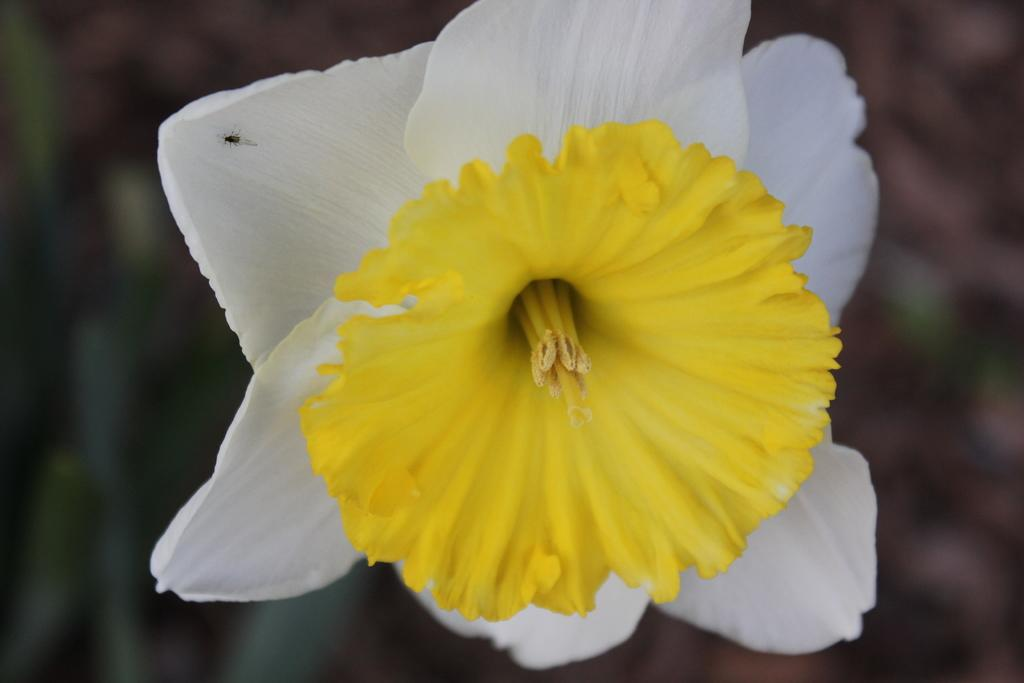What is the main subject of the image? There is a flower in the image. Can you describe the color of the flower? The flower is yellow and white in color. Is there anything else present on the flower? Yes, there is an insect on the flower. What can be seen in the background of the image? There are blurry objects in the background of the image. What type of love can be seen between the flower and the porter in the image? There is no porter present in the image, and the flower is not interacting with any other subject in a way that could be described as love. 